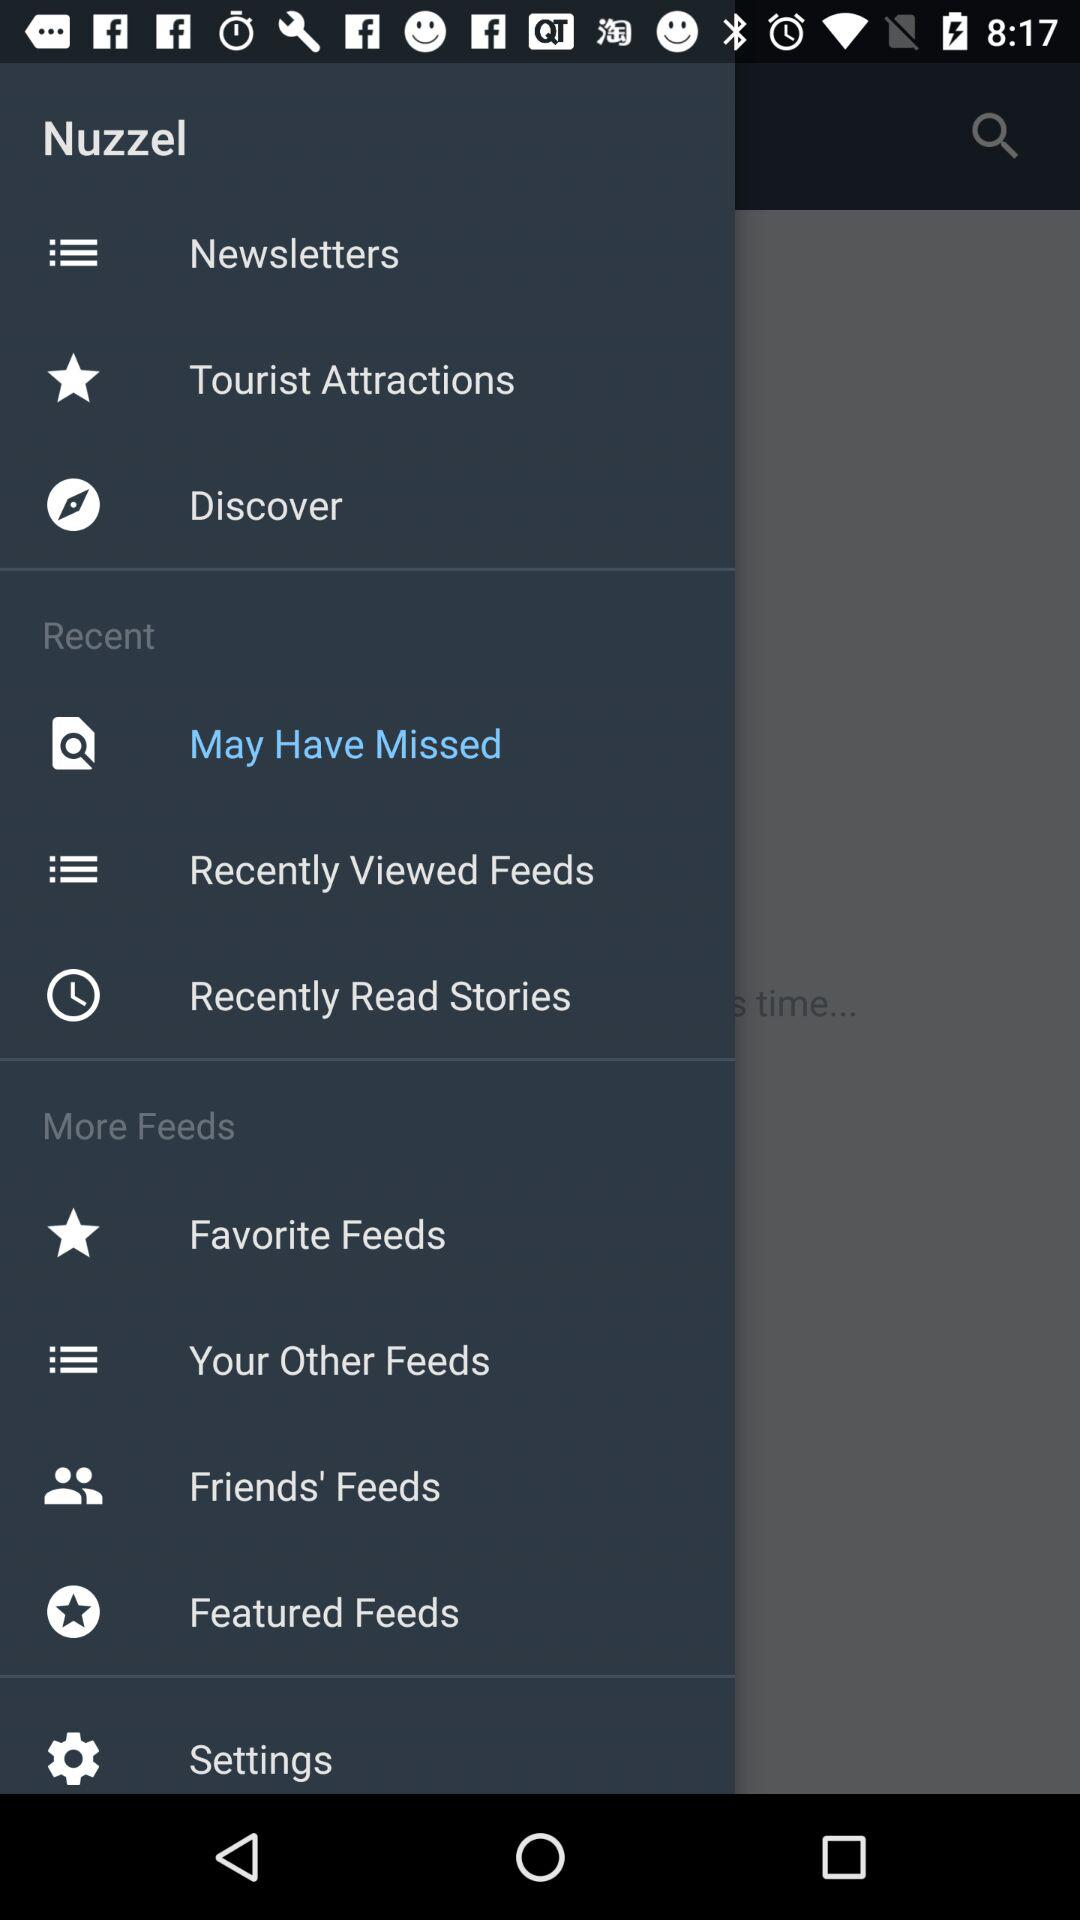How many notifications are there in "Settings"?
When the provided information is insufficient, respond with <no answer>. <no answer> 